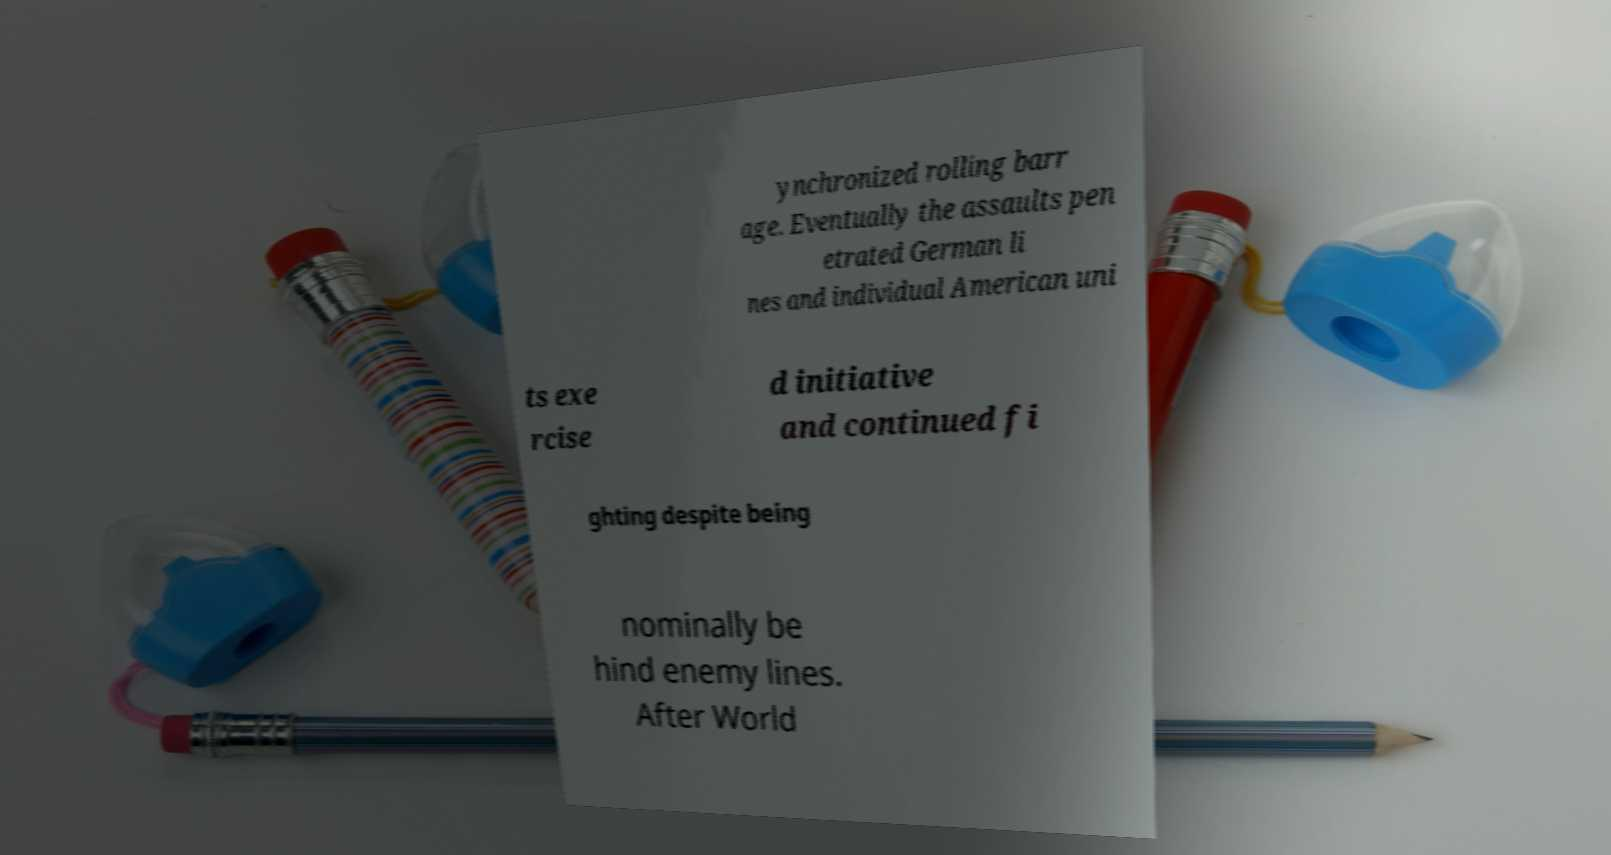Can you accurately transcribe the text from the provided image for me? ynchronized rolling barr age. Eventually the assaults pen etrated German li nes and individual American uni ts exe rcise d initiative and continued fi ghting despite being nominally be hind enemy lines. After World 